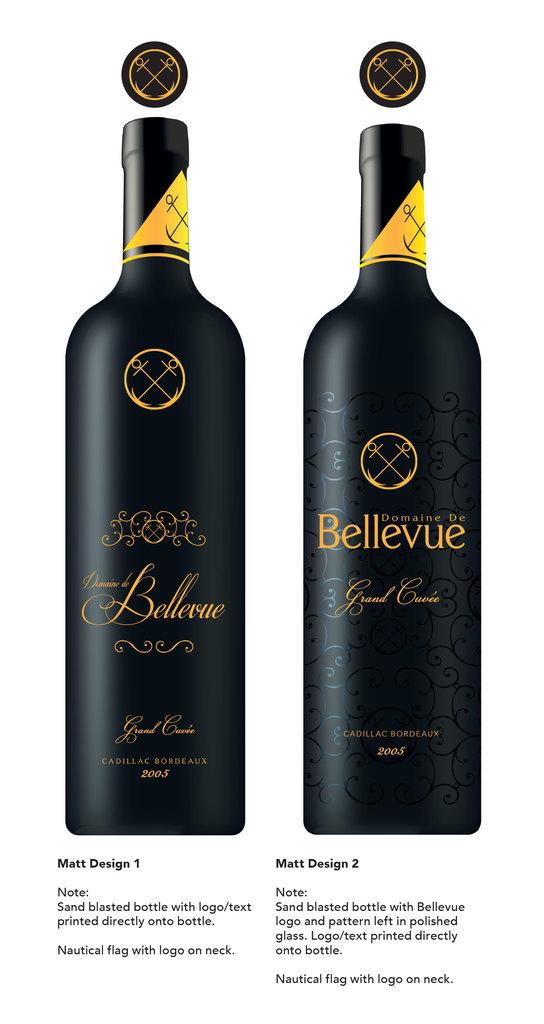Who makes both these bottles?
Keep it short and to the point. Bellevue. What year are the bottles?
Make the answer very short. 2005. 